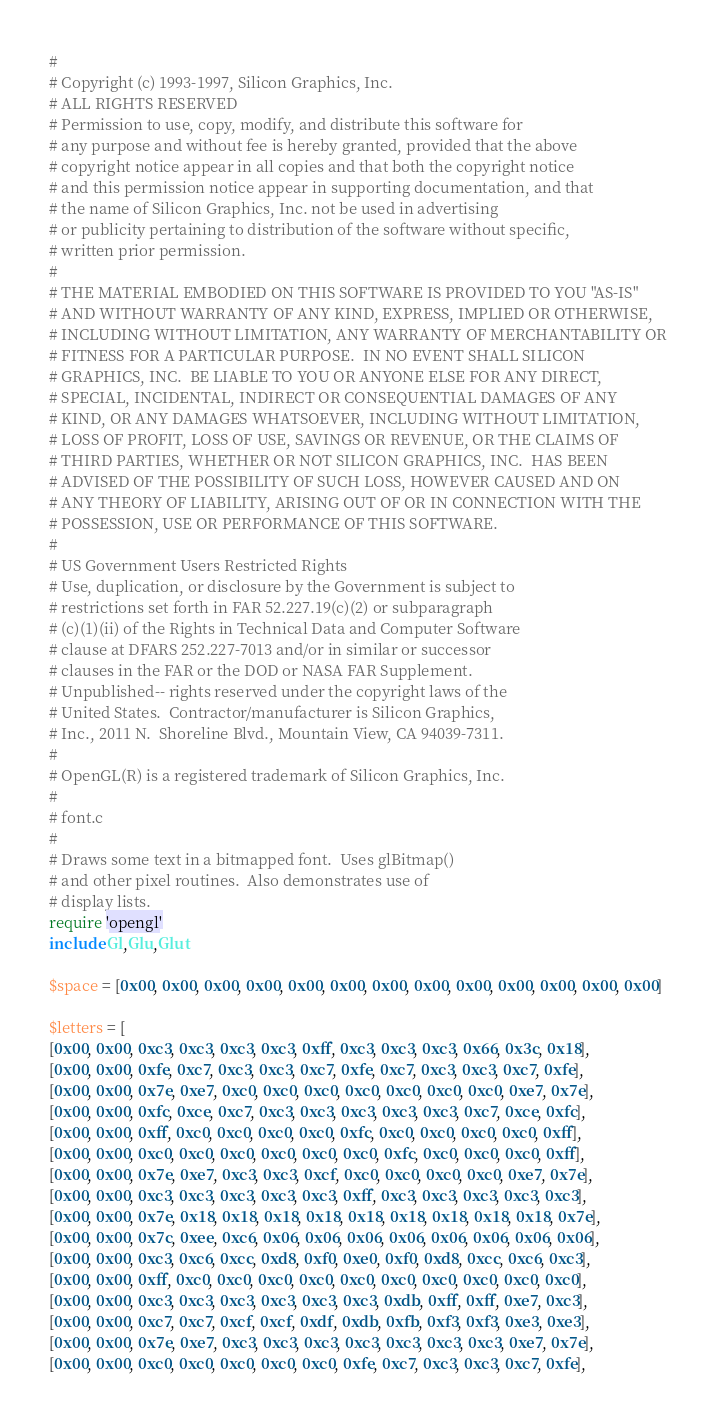Convert code to text. <code><loc_0><loc_0><loc_500><loc_500><_Ruby_>#
# Copyright (c) 1993-1997, Silicon Graphics, Inc.
# ALL RIGHTS RESERVED
# Permission to use, copy, modify, and distribute this software for
# any purpose and without fee is hereby granted, provided that the above
# copyright notice appear in all copies and that both the copyright notice
# and this permission notice appear in supporting documentation, and that
# the name of Silicon Graphics, Inc. not be used in advertising
# or publicity pertaining to distribution of the software without specific,
# written prior permission.
#
# THE MATERIAL EMBODIED ON THIS SOFTWARE IS PROVIDED TO YOU "AS-IS"
# AND WITHOUT WARRANTY OF ANY KIND, EXPRESS, IMPLIED OR OTHERWISE,
# INCLUDING WITHOUT LIMITATION, ANY WARRANTY OF MERCHANTABILITY OR
# FITNESS FOR A PARTICULAR PURPOSE.  IN NO EVENT SHALL SILICON
# GRAPHICS, INC.  BE LIABLE TO YOU OR ANYONE ELSE FOR ANY DIRECT,
# SPECIAL, INCIDENTAL, INDIRECT OR CONSEQUENTIAL DAMAGES OF ANY
# KIND, OR ANY DAMAGES WHATSOEVER, INCLUDING WITHOUT LIMITATION,
# LOSS OF PROFIT, LOSS OF USE, SAVINGS OR REVENUE, OR THE CLAIMS OF
# THIRD PARTIES, WHETHER OR NOT SILICON GRAPHICS, INC.  HAS BEEN
# ADVISED OF THE POSSIBILITY OF SUCH LOSS, HOWEVER CAUSED AND ON
# ANY THEORY OF LIABILITY, ARISING OUT OF OR IN CONNECTION WITH THE
# POSSESSION, USE OR PERFORMANCE OF THIS SOFTWARE.
#
# US Government Users Restricted Rights
# Use, duplication, or disclosure by the Government is subject to
# restrictions set forth in FAR 52.227.19(c)(2) or subparagraph
# (c)(1)(ii) of the Rights in Technical Data and Computer Software
# clause at DFARS 252.227-7013 and/or in similar or successor
# clauses in the FAR or the DOD or NASA FAR Supplement.
# Unpublished-- rights reserved under the copyright laws of the
# United States.  Contractor/manufacturer is Silicon Graphics,
# Inc., 2011 N.  Shoreline Blvd., Mountain View, CA 94039-7311.
#
# OpenGL(R) is a registered trademark of Silicon Graphics, Inc.
#
# font.c
#
# Draws some text in a bitmapped font.  Uses glBitmap()
# and other pixel routines.  Also demonstrates use of
# display lists.
require 'opengl'
include Gl,Glu,Glut

$space = [0x00, 0x00, 0x00, 0x00, 0x00, 0x00, 0x00, 0x00, 0x00, 0x00, 0x00, 0x00, 0x00]

$letters = [
[0x00, 0x00, 0xc3, 0xc3, 0xc3, 0xc3, 0xff, 0xc3, 0xc3, 0xc3, 0x66, 0x3c, 0x18],
[0x00, 0x00, 0xfe, 0xc7, 0xc3, 0xc3, 0xc7, 0xfe, 0xc7, 0xc3, 0xc3, 0xc7, 0xfe],
[0x00, 0x00, 0x7e, 0xe7, 0xc0, 0xc0, 0xc0, 0xc0, 0xc0, 0xc0, 0xc0, 0xe7, 0x7e],
[0x00, 0x00, 0xfc, 0xce, 0xc7, 0xc3, 0xc3, 0xc3, 0xc3, 0xc3, 0xc7, 0xce, 0xfc],
[0x00, 0x00, 0xff, 0xc0, 0xc0, 0xc0, 0xc0, 0xfc, 0xc0, 0xc0, 0xc0, 0xc0, 0xff],
[0x00, 0x00, 0xc0, 0xc0, 0xc0, 0xc0, 0xc0, 0xc0, 0xfc, 0xc0, 0xc0, 0xc0, 0xff],
[0x00, 0x00, 0x7e, 0xe7, 0xc3, 0xc3, 0xcf, 0xc0, 0xc0, 0xc0, 0xc0, 0xe7, 0x7e],
[0x00, 0x00, 0xc3, 0xc3, 0xc3, 0xc3, 0xc3, 0xff, 0xc3, 0xc3, 0xc3, 0xc3, 0xc3],
[0x00, 0x00, 0x7e, 0x18, 0x18, 0x18, 0x18, 0x18, 0x18, 0x18, 0x18, 0x18, 0x7e],
[0x00, 0x00, 0x7c, 0xee, 0xc6, 0x06, 0x06, 0x06, 0x06, 0x06, 0x06, 0x06, 0x06],
[0x00, 0x00, 0xc3, 0xc6, 0xcc, 0xd8, 0xf0, 0xe0, 0xf0, 0xd8, 0xcc, 0xc6, 0xc3],
[0x00, 0x00, 0xff, 0xc0, 0xc0, 0xc0, 0xc0, 0xc0, 0xc0, 0xc0, 0xc0, 0xc0, 0xc0],
[0x00, 0x00, 0xc3, 0xc3, 0xc3, 0xc3, 0xc3, 0xc3, 0xdb, 0xff, 0xff, 0xe7, 0xc3],
[0x00, 0x00, 0xc7, 0xc7, 0xcf, 0xcf, 0xdf, 0xdb, 0xfb, 0xf3, 0xf3, 0xe3, 0xe3],
[0x00, 0x00, 0x7e, 0xe7, 0xc3, 0xc3, 0xc3, 0xc3, 0xc3, 0xc3, 0xc3, 0xe7, 0x7e],
[0x00, 0x00, 0xc0, 0xc0, 0xc0, 0xc0, 0xc0, 0xfe, 0xc7, 0xc3, 0xc3, 0xc7, 0xfe],</code> 